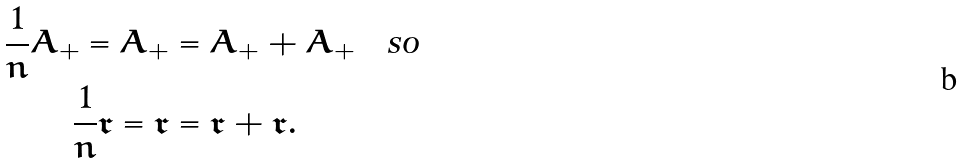Convert formula to latex. <formula><loc_0><loc_0><loc_500><loc_500>\frac { 1 } { n } A _ { + } = A _ { + } & = A _ { + } + A _ { + } \quad \text {so} \\ \frac { 1 } { n } \mathfrak { r } = \mathfrak { r } & = \mathfrak { r } + \mathfrak { r } .</formula> 